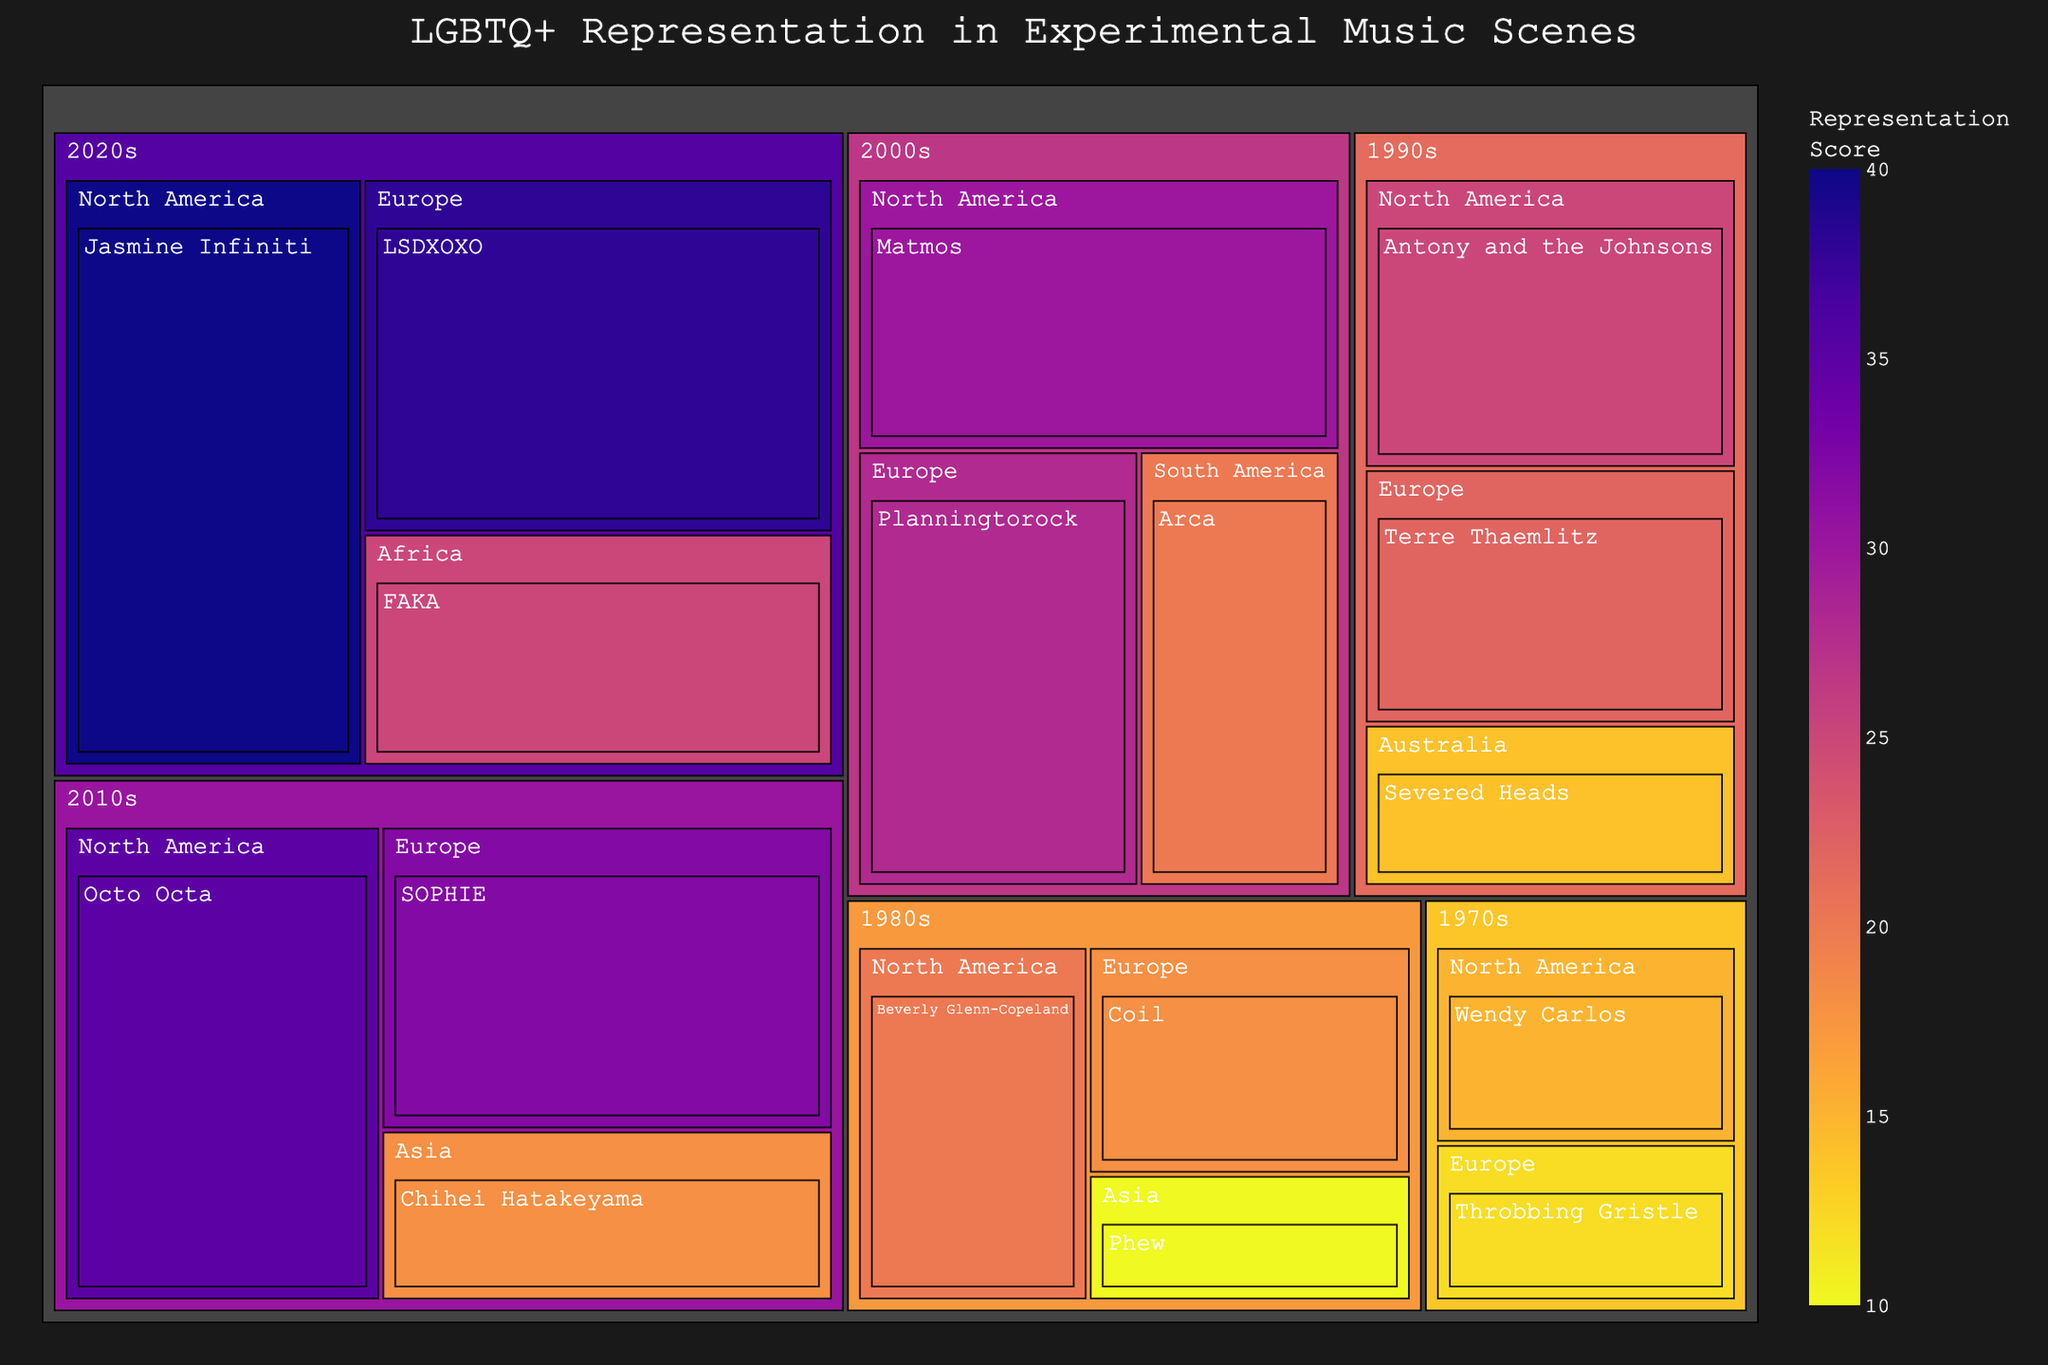What is the title of the Treemap? The title is typically found at the top of the figure, clearly indicating its subject.
Answer: LGBTQ+ Representation in Experimental Music Scenes Which decade has the highest representation score in North America? Look for the decade with the highest value associated with North America in the treemap.
Answer: 2020s How many regions are represented in the 2010s? Identify the number of distinct regions listed under the 2010s in the treemap.
Answer: 3 Which LGBTQ+ artist/group has the highest representation score in Europe? Check for the artist/group listed under Europe with the highest numerical value.
Answer: LSDXOXO Compare the representation score of Beverly Glenn-Copeland and Antony and the Johnsons. Locate the representation scores of both artists and see which one is greater. Beverly Glenn-Copeland has a score of 20 and Antony and the Johnsons has a score of 25.
Answer: Antony and the Johnsons What is the total representation score for the 1990s? Sum the representation scores of all the artists/groups listed under the 1990s. 25 (Antony and the Johnsons) + 22 (Terre Thaemlitz) + 14 (Severed Heads) = 61
Answer: 61 What is the average representation score for artists/groups in Europe for the 2020s? Average the scores of all artists/groups listed under Europe in the 2020s. (38 for LSDXOXO)/1 = 38
Answer: 38 Identify an artist with a representation score of 18 and mention the decade and region they belong to. Find the artist with a score of 18 and look at their associated decade and region.
Answer: Chihei Hatakeyama, 2010s, Asia In which region did Beverly Glenn-Copeland contribute to experimental music? Find Beverly Glenn-Copeland in the treemap and identify the associated region.
Answer: North America 